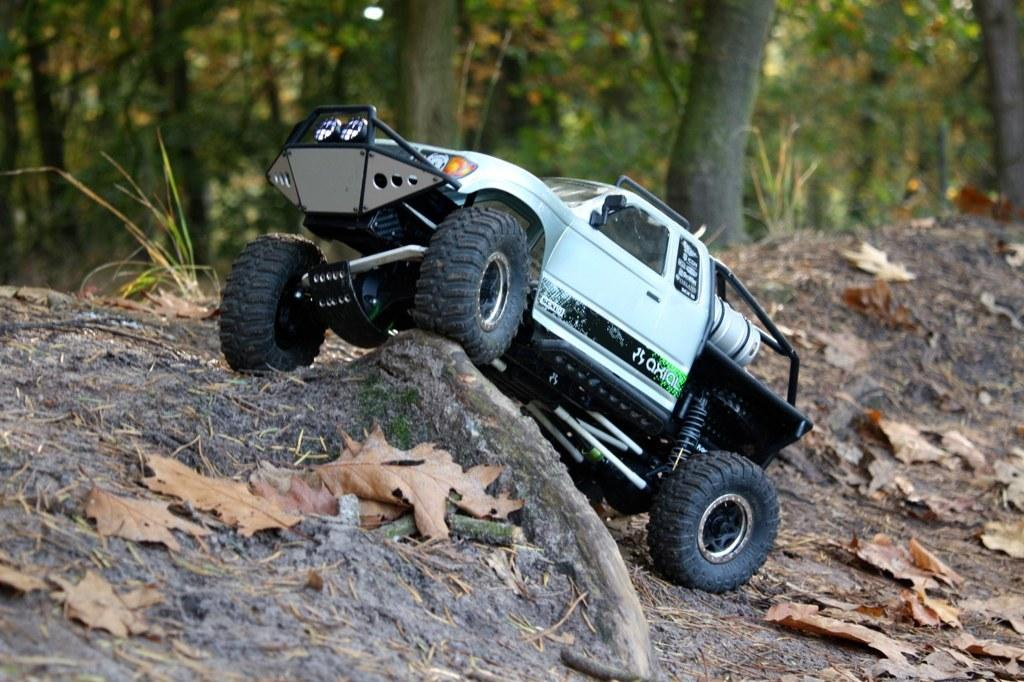What type of toy is present in the image? There is a toy car in the image. What can be seen on the ground in the image? There are leaves on the ground in the image. What type of vegetation is visible in the image? There are trees and grass in the image. How would you describe the background of the image? The background of the image is blurred. What type of beef is being prepared in the image? There is no beef present in the image; it features a toy car and natural elements like leaves, trees, and grass. Can you see a needle in the image? There is no needle present in the image. 